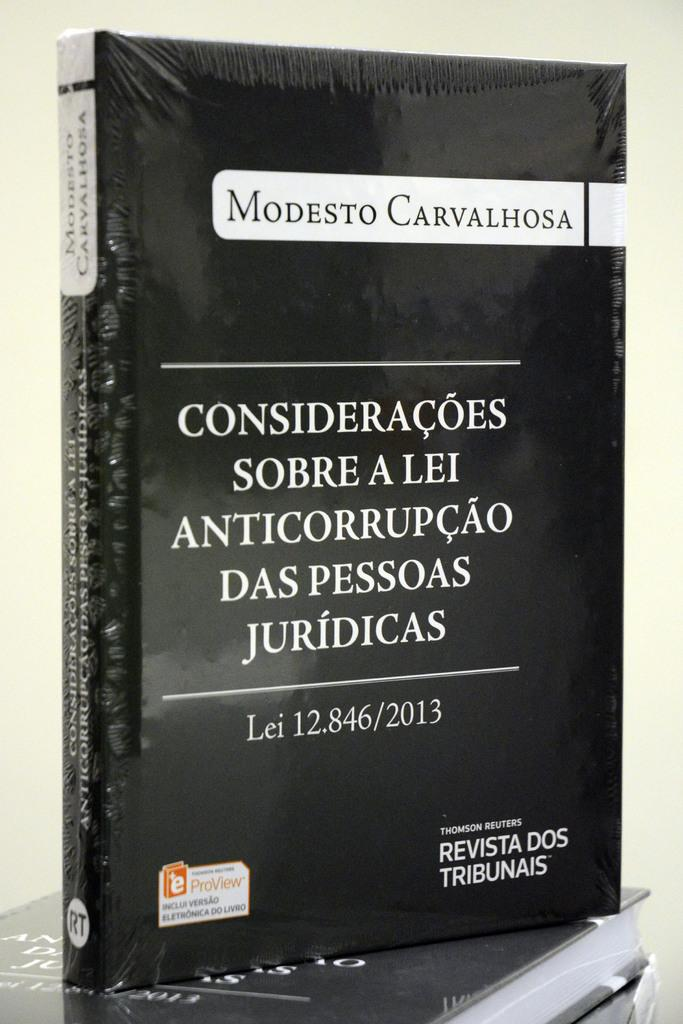<image>
Provide a brief description of the given image. The book with the black cover was written by Modesto Carvalhosa. 